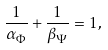Convert formula to latex. <formula><loc_0><loc_0><loc_500><loc_500>\frac { 1 } { \alpha _ { \Phi } } + \frac { 1 } { \beta _ { \Psi } } = 1 ,</formula> 